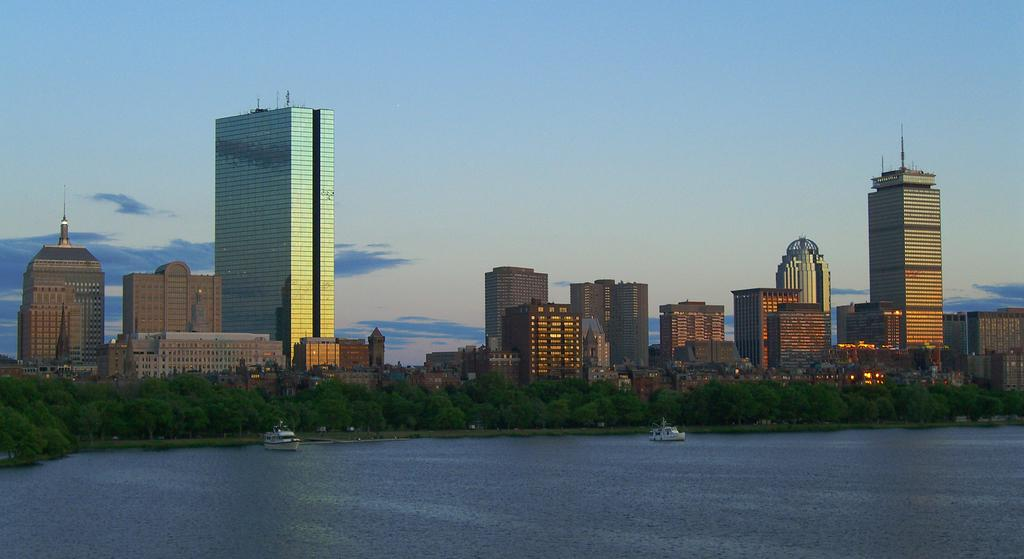What type of structures can be seen in the image? There are buildings in the image. What other natural elements are present in the image? There are trees in the image. What mode of transportation can be seen in the image? There are boats in the image. What is the primary body of water in the image? There is water visible in the image. What can be seen in the background of the image? The sky is visible in the background of the image, and there are clouds in the sky. What type of notebook is being used to glue the comfort of the image? There is no notebook, glue, or comfort present in the image; it features buildings, trees, boats, water, and a sky with clouds. 